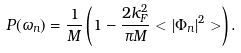Convert formula to latex. <formula><loc_0><loc_0><loc_500><loc_500>P ( \omega _ { n } ) = \frac { 1 } { M } \left ( 1 - \frac { 2 k _ { F } ^ { 2 } } { \pi M } < | \Phi _ { n } | ^ { 2 } > \right ) .</formula> 